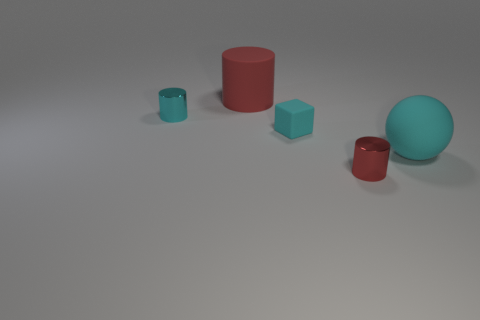Are there any small purple shiny things?
Offer a terse response. No. What is the size of the rubber object that is right of the red thing on the right side of the cyan rubber cube?
Give a very brief answer. Large. Is the number of big red rubber things that are on the left side of the large rubber cylinder greater than the number of matte things to the left of the red metal cylinder?
Keep it short and to the point. No. What number of cubes are either small things or big matte objects?
Make the answer very short. 1. Are there any other things that are the same size as the red matte cylinder?
Offer a very short reply. Yes. Do the big matte thing that is to the left of the matte sphere and the tiny cyan metal object have the same shape?
Your answer should be compact. Yes. The large ball has what color?
Give a very brief answer. Cyan. What color is the other small thing that is the same shape as the cyan shiny thing?
Offer a very short reply. Red. How many big red things have the same shape as the tiny red thing?
Ensure brevity in your answer.  1. What number of objects are large red cylinders or tiny cyan objects on the right side of the red matte thing?
Make the answer very short. 2. 